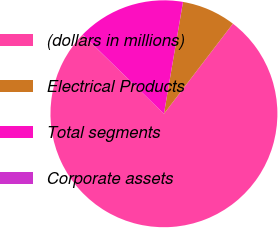Convert chart. <chart><loc_0><loc_0><loc_500><loc_500><pie_chart><fcel>(dollars in millions)<fcel>Electrical Products<fcel>Total segments<fcel>Corporate assets<nl><fcel>76.88%<fcel>7.71%<fcel>15.39%<fcel>0.02%<nl></chart> 